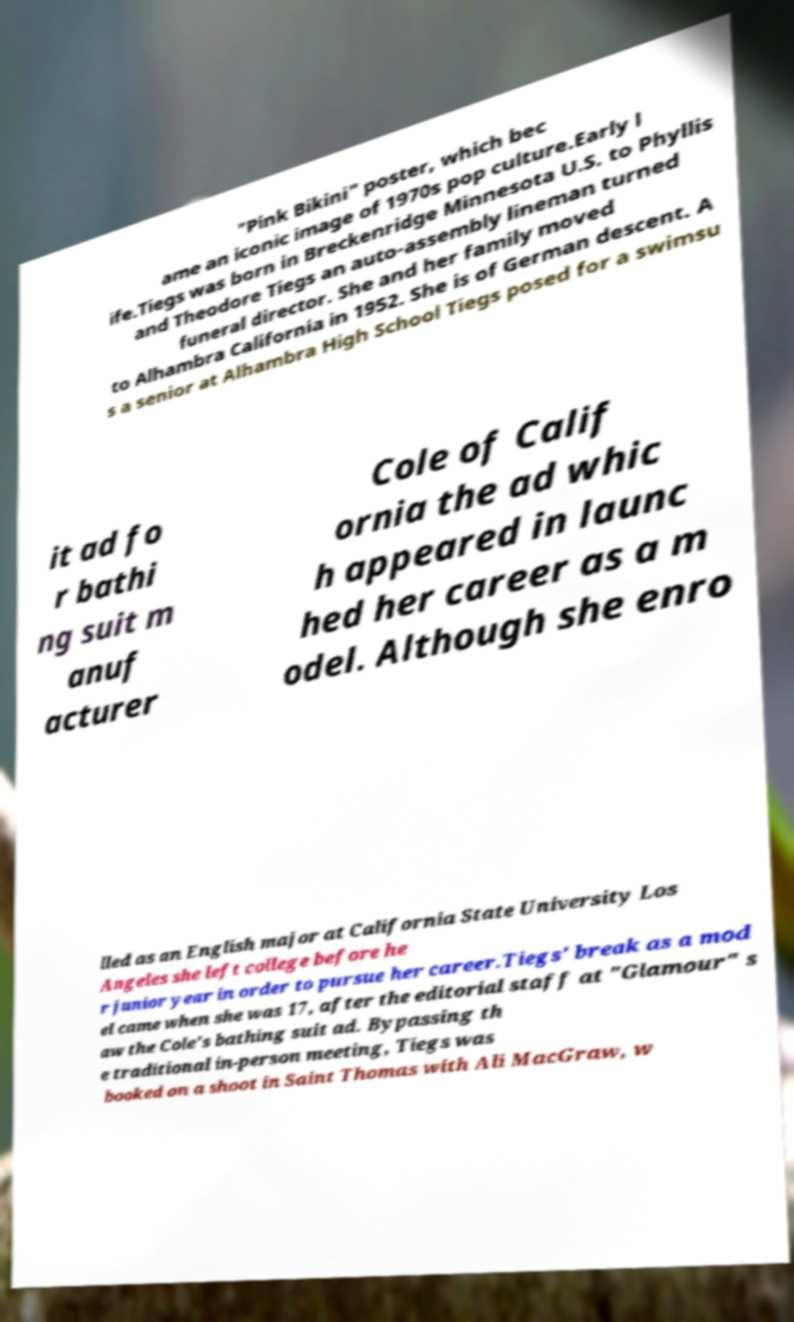Can you accurately transcribe the text from the provided image for me? "Pink Bikini" poster, which bec ame an iconic image of 1970s pop culture.Early l ife.Tiegs was born in Breckenridge Minnesota U.S. to Phyllis and Theodore Tiegs an auto-assembly lineman turned funeral director. She and her family moved to Alhambra California in 1952. She is of German descent. A s a senior at Alhambra High School Tiegs posed for a swimsu it ad fo r bathi ng suit m anuf acturer Cole of Calif ornia the ad whic h appeared in launc hed her career as a m odel. Although she enro lled as an English major at California State University Los Angeles she left college before he r junior year in order to pursue her career.Tiegs' break as a mod el came when she was 17, after the editorial staff at "Glamour" s aw the Cole's bathing suit ad. Bypassing th e traditional in-person meeting, Tiegs was booked on a shoot in Saint Thomas with Ali MacGraw, w 